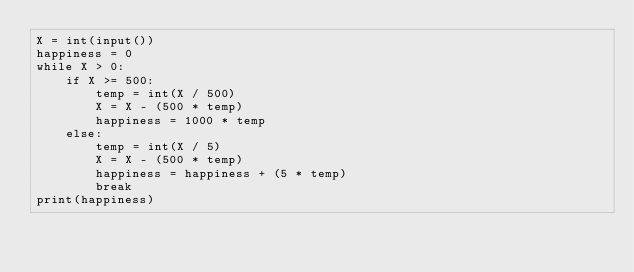<code> <loc_0><loc_0><loc_500><loc_500><_Python_>X = int(input())
happiness = 0
while X > 0:
    if X >= 500:
        temp = int(X / 500)
        X = X - (500 * temp)
        happiness = 1000 * temp
    else:
        temp = int(X / 5)
        X = X - (500 * temp)
        happiness = happiness + (5 * temp)
        break
print(happiness)</code> 